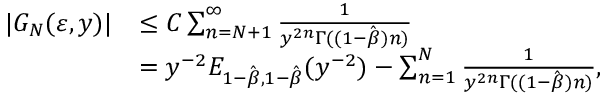Convert formula to latex. <formula><loc_0><loc_0><loc_500><loc_500>\begin{array} { r l } { | G _ { N } ( \varepsilon , y ) | } & { \leq C \sum _ { n = N + 1 } ^ { \infty } \frac { 1 } { y ^ { 2 n } \Gamma ( ( 1 - \hat { \beta } ) n ) } } \\ & { = y ^ { - 2 } E _ { 1 - \hat { \beta } , 1 - \hat { \beta } } ( y ^ { - 2 } ) - \sum _ { n = 1 } ^ { N } \frac { 1 } { y ^ { 2 n } \Gamma ( ( 1 - \hat { \beta } ) n ) } , } \end{array}</formula> 